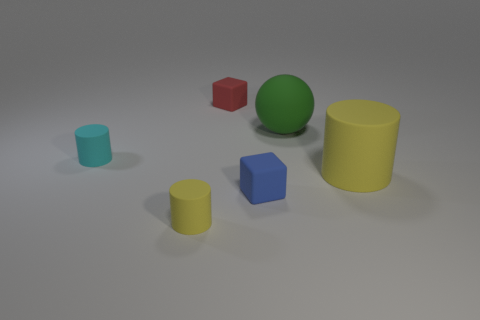What can you infer about the lighting source in the scene based on the shadows? The shadows in the scene are soft and extend to the right side of the objects, suggesting that the primary light source is coming from the top left. The diffuse nature of the shadows indicates that the light may be ambient or diffused through a softbox or similar device to avoid harsh direct light. 